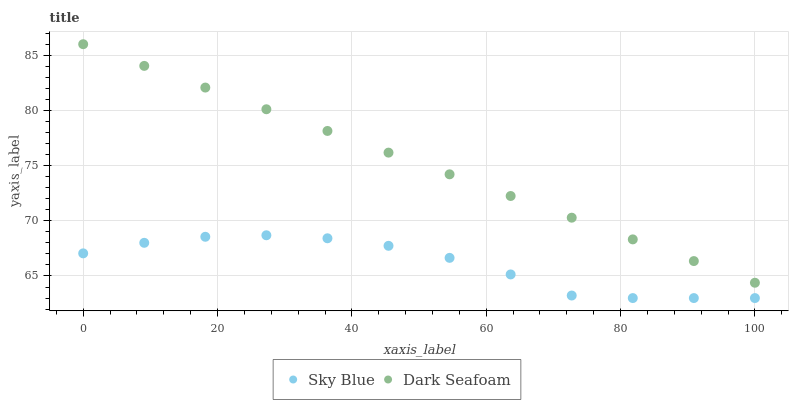Does Sky Blue have the minimum area under the curve?
Answer yes or no. Yes. Does Dark Seafoam have the maximum area under the curve?
Answer yes or no. Yes. Does Dark Seafoam have the minimum area under the curve?
Answer yes or no. No. Is Dark Seafoam the smoothest?
Answer yes or no. Yes. Is Sky Blue the roughest?
Answer yes or no. Yes. Is Dark Seafoam the roughest?
Answer yes or no. No. Does Sky Blue have the lowest value?
Answer yes or no. Yes. Does Dark Seafoam have the lowest value?
Answer yes or no. No. Does Dark Seafoam have the highest value?
Answer yes or no. Yes. Is Sky Blue less than Dark Seafoam?
Answer yes or no. Yes. Is Dark Seafoam greater than Sky Blue?
Answer yes or no. Yes. Does Sky Blue intersect Dark Seafoam?
Answer yes or no. No. 